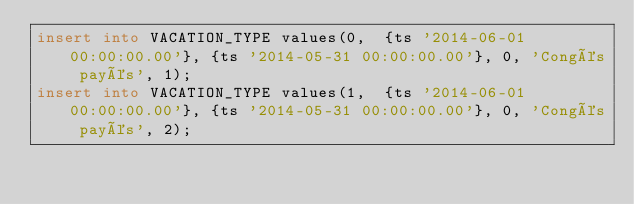<code> <loc_0><loc_0><loc_500><loc_500><_SQL_>insert into VACATION_TYPE values(0,  {ts '2014-06-01 00:00:00.00'}, {ts '2014-05-31 00:00:00.00'}, 0, 'Congés payés', 1);
insert into VACATION_TYPE values(1,  {ts '2014-06-01 00:00:00.00'}, {ts '2014-05-31 00:00:00.00'}, 0, 'Congés payés', 2);
</code> 